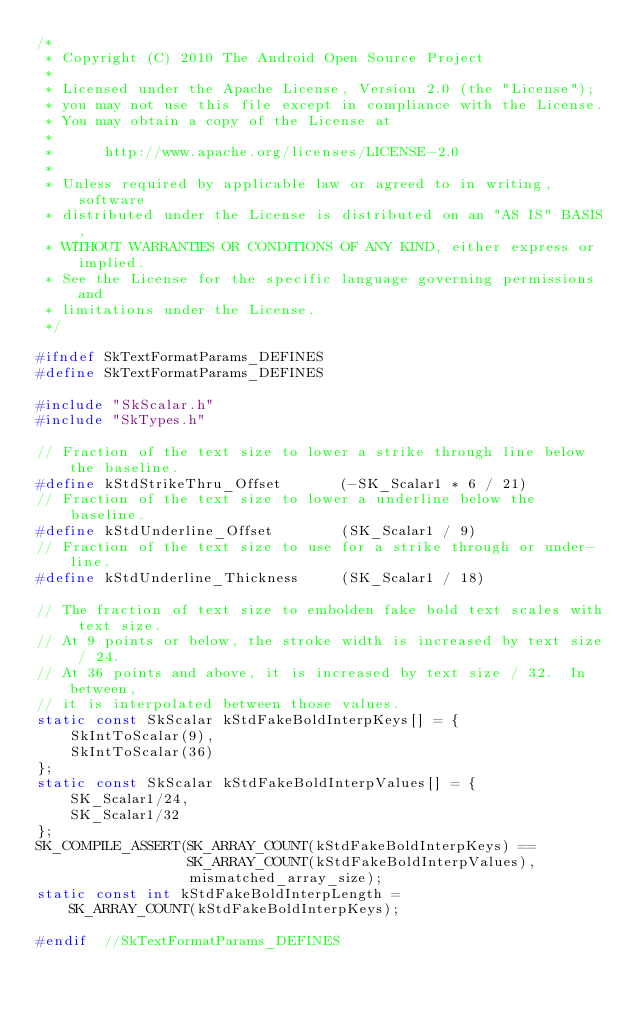<code> <loc_0><loc_0><loc_500><loc_500><_C_>/*
 * Copyright (C) 2010 The Android Open Source Project
 *
 * Licensed under the Apache License, Version 2.0 (the "License");
 * you may not use this file except in compliance with the License.
 * You may obtain a copy of the License at
 *
 *      http://www.apache.org/licenses/LICENSE-2.0
 *
 * Unless required by applicable law or agreed to in writing, software
 * distributed under the License is distributed on an "AS IS" BASIS,
 * WITHOUT WARRANTIES OR CONDITIONS OF ANY KIND, either express or implied.
 * See the License for the specific language governing permissions and
 * limitations under the License.
 */

#ifndef SkTextFormatParams_DEFINES
#define SkTextFormatParams_DEFINES

#include "SkScalar.h"
#include "SkTypes.h"

// Fraction of the text size to lower a strike through line below the baseline.
#define kStdStrikeThru_Offset       (-SK_Scalar1 * 6 / 21)
// Fraction of the text size to lower a underline below the baseline.
#define kStdUnderline_Offset        (SK_Scalar1 / 9)
// Fraction of the text size to use for a strike through or under-line.
#define kStdUnderline_Thickness     (SK_Scalar1 / 18)

// The fraction of text size to embolden fake bold text scales with text size.
// At 9 points or below, the stroke width is increased by text size / 24.
// At 36 points and above, it is increased by text size / 32.  In between,
// it is interpolated between those values.
static const SkScalar kStdFakeBoldInterpKeys[] = {
    SkIntToScalar(9),
    SkIntToScalar(36)
};
static const SkScalar kStdFakeBoldInterpValues[] = {
    SK_Scalar1/24,
    SK_Scalar1/32
};
SK_COMPILE_ASSERT(SK_ARRAY_COUNT(kStdFakeBoldInterpKeys) ==
                  SK_ARRAY_COUNT(kStdFakeBoldInterpValues),
                  mismatched_array_size);
static const int kStdFakeBoldInterpLength =
    SK_ARRAY_COUNT(kStdFakeBoldInterpKeys);

#endif  //SkTextFormatParams_DEFINES
</code> 